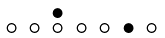<formula> <loc_0><loc_0><loc_500><loc_500>\begin{smallmatrix} & & \bullet \\ \circ & \circ & \circ & \circ & \circ & \bullet & \circ & \\ \end{smallmatrix}</formula> 